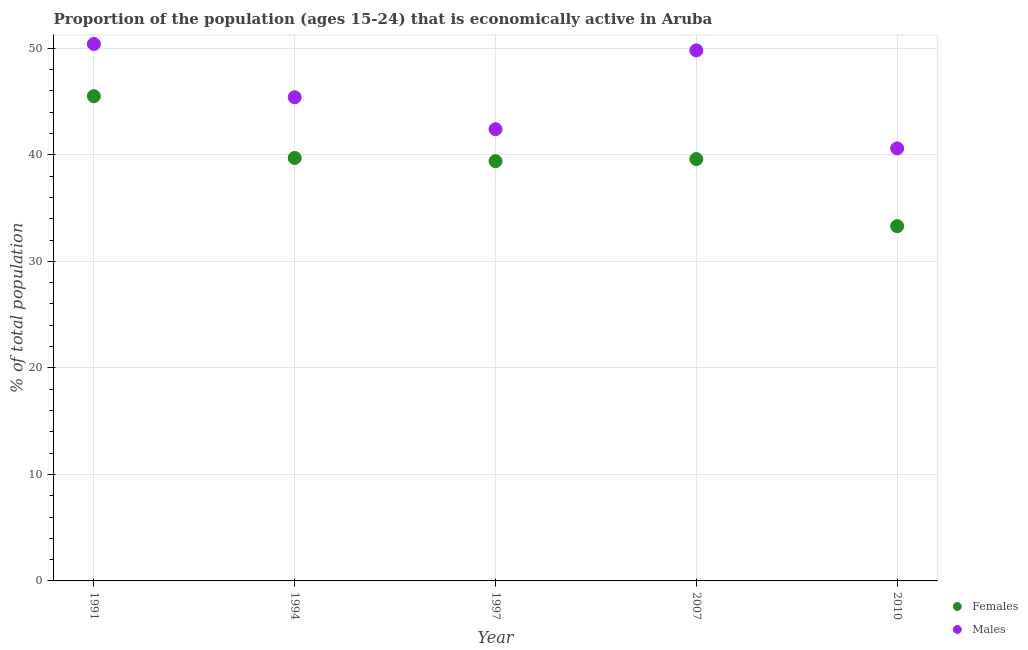What is the percentage of economically active male population in 1994?
Ensure brevity in your answer.  45.4. Across all years, what is the maximum percentage of economically active female population?
Offer a very short reply. 45.5. Across all years, what is the minimum percentage of economically active female population?
Give a very brief answer. 33.3. In which year was the percentage of economically active male population maximum?
Your answer should be very brief. 1991. What is the total percentage of economically active female population in the graph?
Keep it short and to the point. 197.5. What is the difference between the percentage of economically active female population in 2007 and that in 2010?
Your response must be concise. 6.3. What is the average percentage of economically active female population per year?
Offer a terse response. 39.5. In the year 2010, what is the difference between the percentage of economically active male population and percentage of economically active female population?
Provide a succinct answer. 7.3. In how many years, is the percentage of economically active female population greater than 6 %?
Your answer should be very brief. 5. What is the ratio of the percentage of economically active female population in 1997 to that in 2010?
Your answer should be very brief. 1.18. What is the difference between the highest and the second highest percentage of economically active male population?
Make the answer very short. 0.6. What is the difference between the highest and the lowest percentage of economically active male population?
Provide a succinct answer. 9.8. Is the sum of the percentage of economically active female population in 1991 and 1997 greater than the maximum percentage of economically active male population across all years?
Your answer should be compact. Yes. Is the percentage of economically active female population strictly greater than the percentage of economically active male population over the years?
Offer a very short reply. No. Is the percentage of economically active male population strictly less than the percentage of economically active female population over the years?
Ensure brevity in your answer.  No. How many years are there in the graph?
Offer a terse response. 5. Where does the legend appear in the graph?
Give a very brief answer. Bottom right. How many legend labels are there?
Offer a terse response. 2. What is the title of the graph?
Make the answer very short. Proportion of the population (ages 15-24) that is economically active in Aruba. Does "Foreign Liabilities" appear as one of the legend labels in the graph?
Offer a very short reply. No. What is the label or title of the X-axis?
Ensure brevity in your answer.  Year. What is the label or title of the Y-axis?
Provide a succinct answer. % of total population. What is the % of total population in Females in 1991?
Offer a very short reply. 45.5. What is the % of total population in Males in 1991?
Your response must be concise. 50.4. What is the % of total population in Females in 1994?
Your response must be concise. 39.7. What is the % of total population of Males in 1994?
Keep it short and to the point. 45.4. What is the % of total population in Females in 1997?
Your response must be concise. 39.4. What is the % of total population in Males in 1997?
Make the answer very short. 42.4. What is the % of total population in Females in 2007?
Keep it short and to the point. 39.6. What is the % of total population in Males in 2007?
Give a very brief answer. 49.8. What is the % of total population of Females in 2010?
Provide a short and direct response. 33.3. What is the % of total population of Males in 2010?
Your answer should be very brief. 40.6. Across all years, what is the maximum % of total population of Females?
Provide a short and direct response. 45.5. Across all years, what is the maximum % of total population of Males?
Offer a very short reply. 50.4. Across all years, what is the minimum % of total population in Females?
Offer a terse response. 33.3. Across all years, what is the minimum % of total population in Males?
Ensure brevity in your answer.  40.6. What is the total % of total population of Females in the graph?
Offer a very short reply. 197.5. What is the total % of total population of Males in the graph?
Provide a short and direct response. 228.6. What is the difference between the % of total population in Females in 1991 and that in 1994?
Your answer should be compact. 5.8. What is the difference between the % of total population of Males in 1991 and that in 1994?
Keep it short and to the point. 5. What is the difference between the % of total population of Females in 1991 and that in 1997?
Provide a short and direct response. 6.1. What is the difference between the % of total population in Females in 1991 and that in 2007?
Offer a very short reply. 5.9. What is the difference between the % of total population of Females in 1991 and that in 2010?
Provide a short and direct response. 12.2. What is the difference between the % of total population in Males in 1991 and that in 2010?
Make the answer very short. 9.8. What is the difference between the % of total population of Females in 1994 and that in 1997?
Provide a succinct answer. 0.3. What is the difference between the % of total population in Males in 1994 and that in 1997?
Ensure brevity in your answer.  3. What is the difference between the % of total population of Females in 1994 and that in 2007?
Provide a succinct answer. 0.1. What is the difference between the % of total population in Females in 1997 and that in 2007?
Offer a terse response. -0.2. What is the difference between the % of total population in Males in 1997 and that in 2007?
Your response must be concise. -7.4. What is the difference between the % of total population in Males in 1997 and that in 2010?
Offer a terse response. 1.8. What is the difference between the % of total population of Females in 1991 and the % of total population of Males in 2007?
Ensure brevity in your answer.  -4.3. What is the difference between the % of total population in Females in 1997 and the % of total population in Males in 2010?
Offer a terse response. -1.2. What is the difference between the % of total population in Females in 2007 and the % of total population in Males in 2010?
Provide a short and direct response. -1. What is the average % of total population in Females per year?
Keep it short and to the point. 39.5. What is the average % of total population in Males per year?
Provide a short and direct response. 45.72. In the year 1991, what is the difference between the % of total population of Females and % of total population of Males?
Your answer should be compact. -4.9. In the year 1994, what is the difference between the % of total population of Females and % of total population of Males?
Your answer should be compact. -5.7. What is the ratio of the % of total population in Females in 1991 to that in 1994?
Provide a succinct answer. 1.15. What is the ratio of the % of total population of Males in 1991 to that in 1994?
Offer a very short reply. 1.11. What is the ratio of the % of total population in Females in 1991 to that in 1997?
Keep it short and to the point. 1.15. What is the ratio of the % of total population in Males in 1991 to that in 1997?
Keep it short and to the point. 1.19. What is the ratio of the % of total population in Females in 1991 to that in 2007?
Your response must be concise. 1.15. What is the ratio of the % of total population of Males in 1991 to that in 2007?
Make the answer very short. 1.01. What is the ratio of the % of total population of Females in 1991 to that in 2010?
Your answer should be compact. 1.37. What is the ratio of the % of total population of Males in 1991 to that in 2010?
Offer a terse response. 1.24. What is the ratio of the % of total population in Females in 1994 to that in 1997?
Offer a very short reply. 1.01. What is the ratio of the % of total population in Males in 1994 to that in 1997?
Keep it short and to the point. 1.07. What is the ratio of the % of total population in Females in 1994 to that in 2007?
Keep it short and to the point. 1. What is the ratio of the % of total population of Males in 1994 to that in 2007?
Give a very brief answer. 0.91. What is the ratio of the % of total population in Females in 1994 to that in 2010?
Make the answer very short. 1.19. What is the ratio of the % of total population of Males in 1994 to that in 2010?
Your answer should be compact. 1.12. What is the ratio of the % of total population of Males in 1997 to that in 2007?
Your answer should be compact. 0.85. What is the ratio of the % of total population of Females in 1997 to that in 2010?
Keep it short and to the point. 1.18. What is the ratio of the % of total population in Males in 1997 to that in 2010?
Offer a terse response. 1.04. What is the ratio of the % of total population of Females in 2007 to that in 2010?
Your response must be concise. 1.19. What is the ratio of the % of total population of Males in 2007 to that in 2010?
Provide a short and direct response. 1.23. What is the difference between the highest and the second highest % of total population of Males?
Offer a very short reply. 0.6. What is the difference between the highest and the lowest % of total population in Females?
Keep it short and to the point. 12.2. 